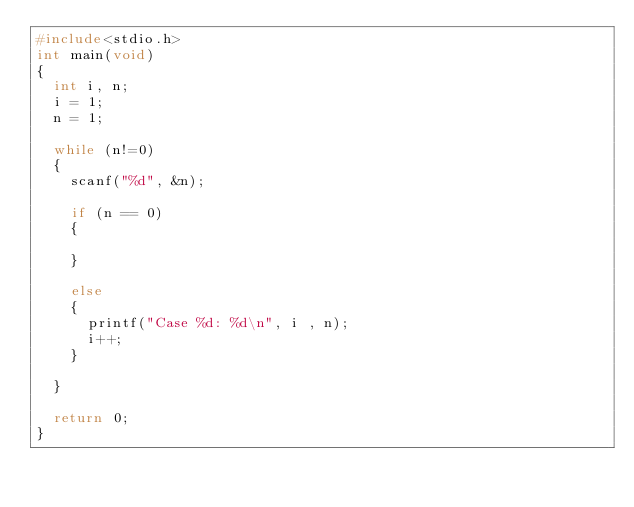<code> <loc_0><loc_0><loc_500><loc_500><_C_>#include<stdio.h>
int main(void)
{
	int i, n;
	i = 1;
	n = 1;

	while (n!=0)
	{
		scanf("%d", &n);

		if (n == 0)
		{
			
		}

		else
		{
			printf("Case %d: %d\n", i , n);
			i++;
		}

	}

	return 0;
}
</code> 